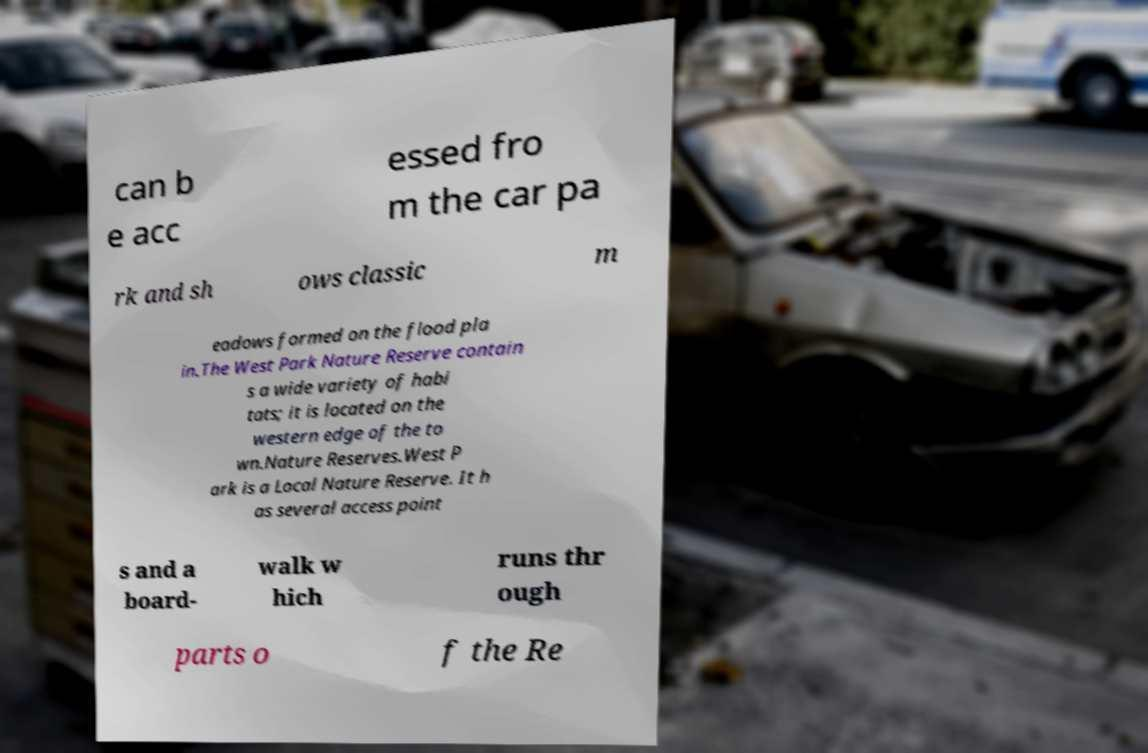There's text embedded in this image that I need extracted. Can you transcribe it verbatim? can b e acc essed fro m the car pa rk and sh ows classic m eadows formed on the flood pla in.The West Park Nature Reserve contain s a wide variety of habi tats; it is located on the western edge of the to wn.Nature Reserves.West P ark is a Local Nature Reserve. It h as several access point s and a board- walk w hich runs thr ough parts o f the Re 